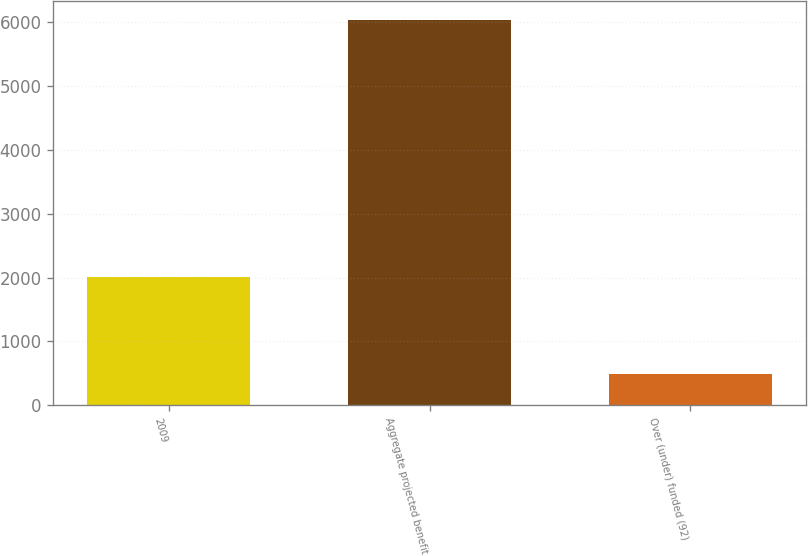<chart> <loc_0><loc_0><loc_500><loc_500><bar_chart><fcel>2009<fcel>Aggregate projected benefit<fcel>Over (under) funded (92)<nl><fcel>2008<fcel>6041<fcel>482<nl></chart> 